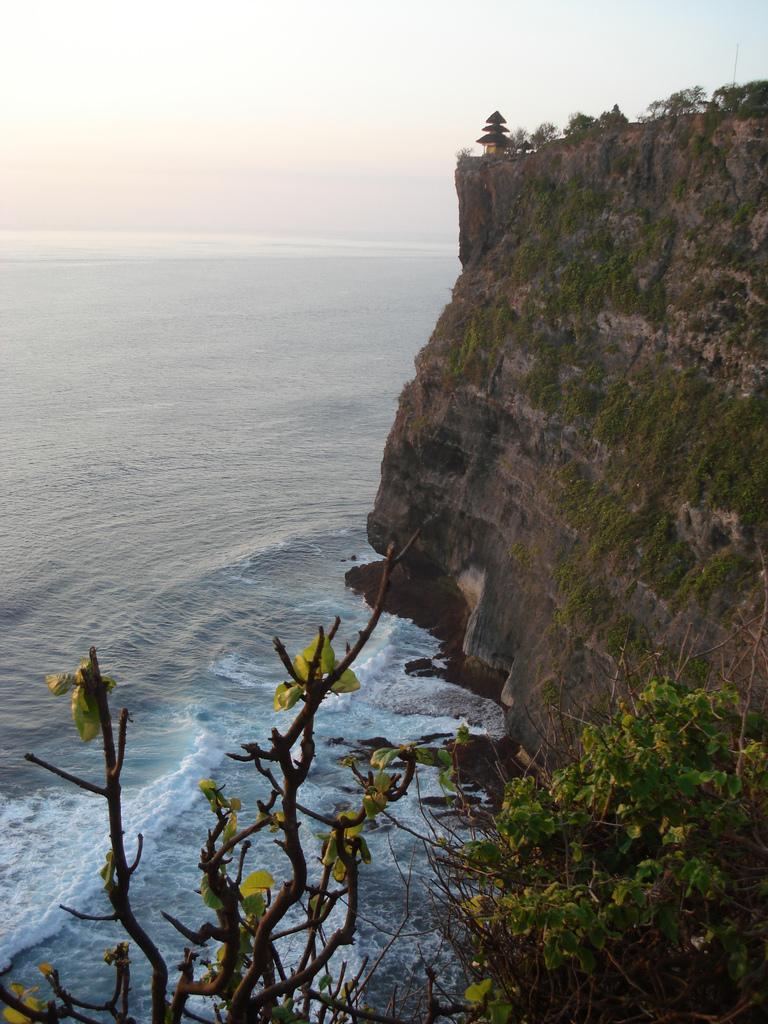In one or two sentences, can you explain what this image depicts? In this picture we can see a hill and some plants, at the bottom there are trees, we can see water in the middle, there is the sky at the top of the picture. 